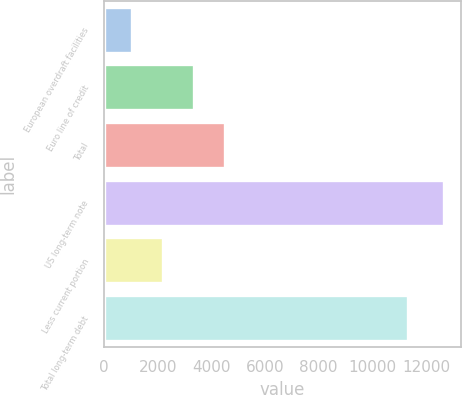Convert chart to OTSL. <chart><loc_0><loc_0><loc_500><loc_500><bar_chart><fcel>European overdraft facilities<fcel>Euro line of credit<fcel>Total<fcel>US long-term note<fcel>Less current portion<fcel>Total long-term debt<nl><fcel>1038<fcel>3363.6<fcel>4526.4<fcel>12666<fcel>2200.8<fcel>11333<nl></chart> 